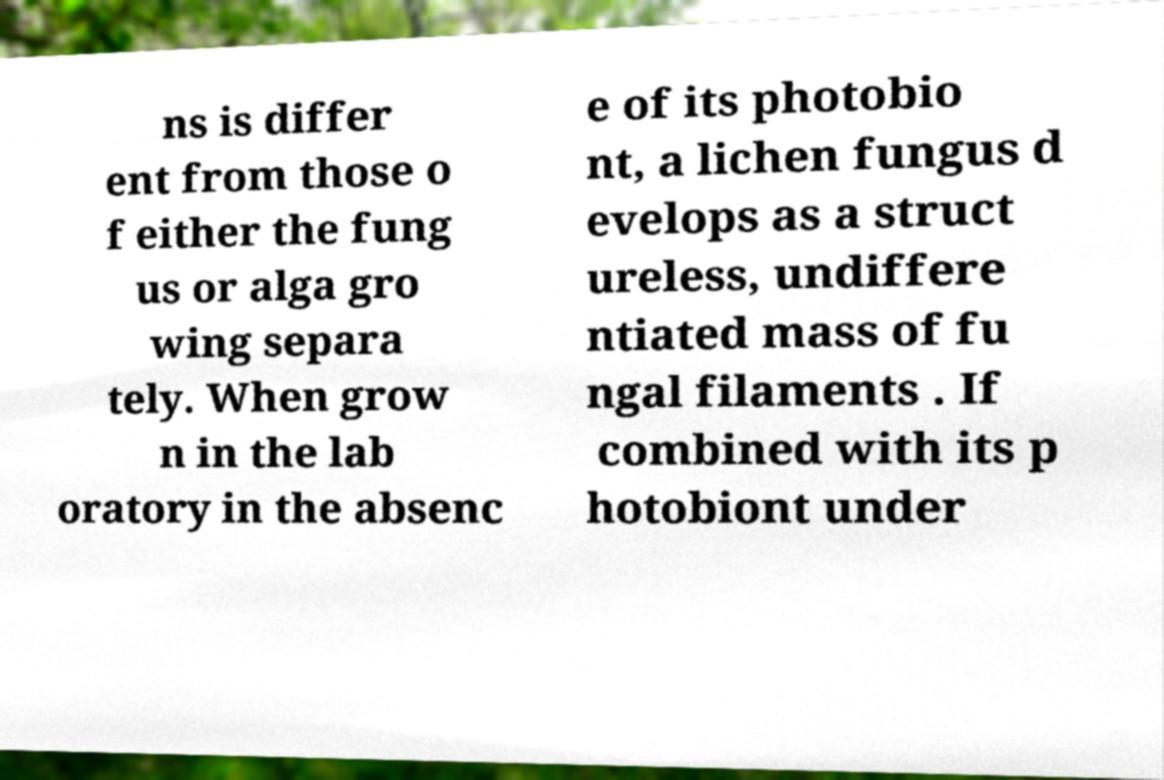Could you extract and type out the text from this image? ns is differ ent from those o f either the fung us or alga gro wing separa tely. When grow n in the lab oratory in the absenc e of its photobio nt, a lichen fungus d evelops as a struct ureless, undiffere ntiated mass of fu ngal filaments . If combined with its p hotobiont under 